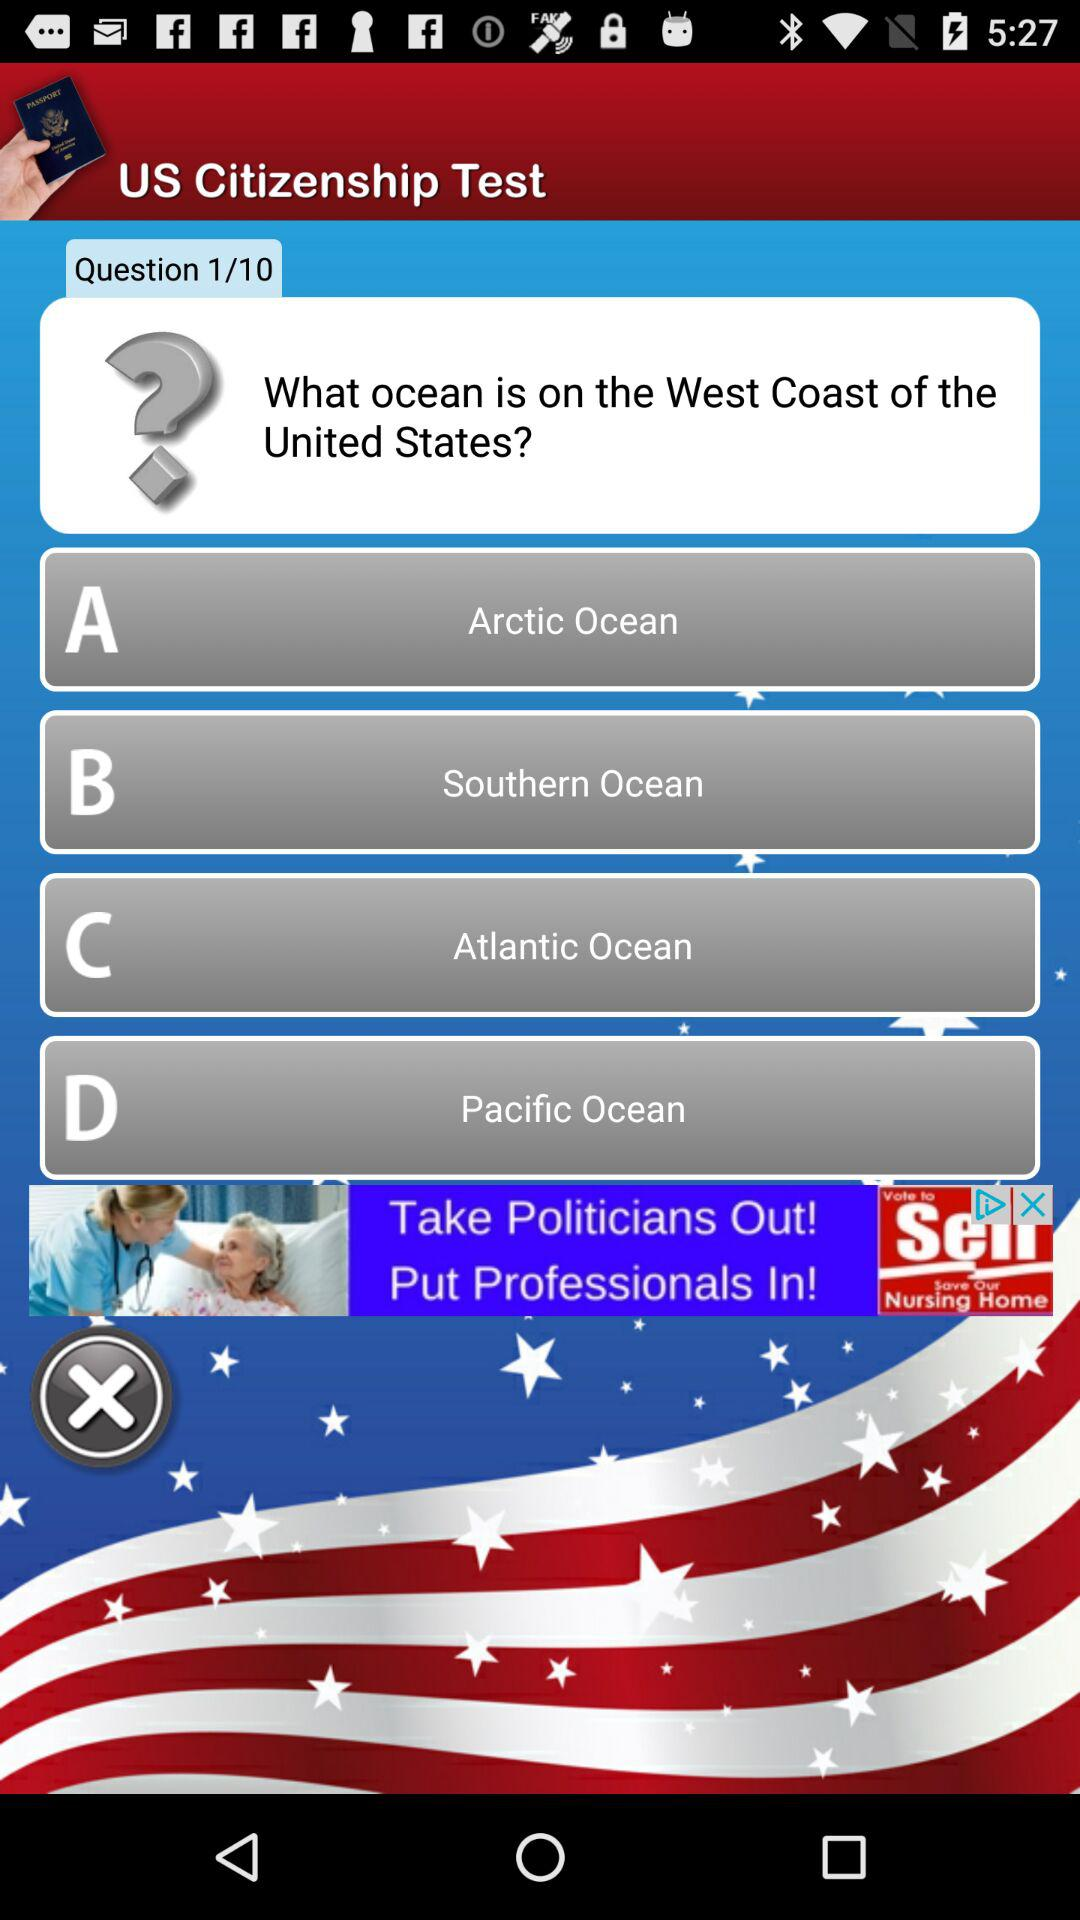How many total questions are there? There are 10 total questions. 